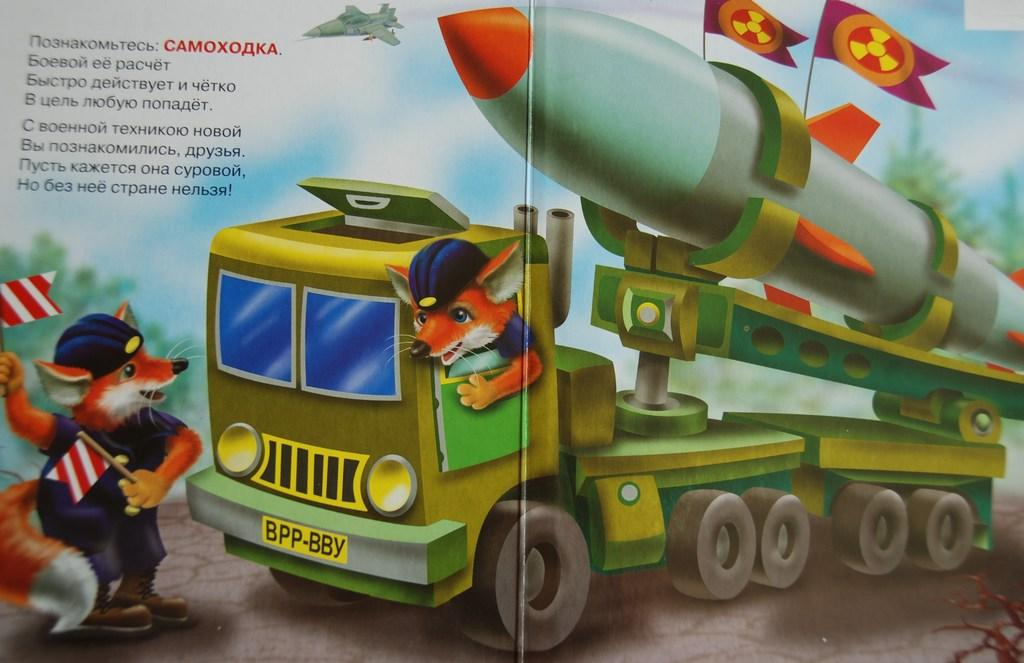What can be seen on the poster in the image? There is a poster in the image, but the specific content is not mentioned in the facts. What type of writing or symbols can be found in the image? There is text in the image, but the content or language is not specified. What mode of transportation is visible in the image? There is a vehicle in the image, but the type or model is not mentioned. What type of animals are present in the image? There are animals in the image, but their species or number is not specified. What national symbols can be seen in the image? There are flags in the image, but the number or design is not mentioned. What type of aircraft is visible in the image? There is an aircraft in the image, but the type or model is not mentioned. Can you tell me how many chairs are depicted in the image? There is no mention of chairs in the image, so it is impossible to determine their presence or number. Is there any magic happening in the image? There is no mention of magic or any supernatural elements in the image. 